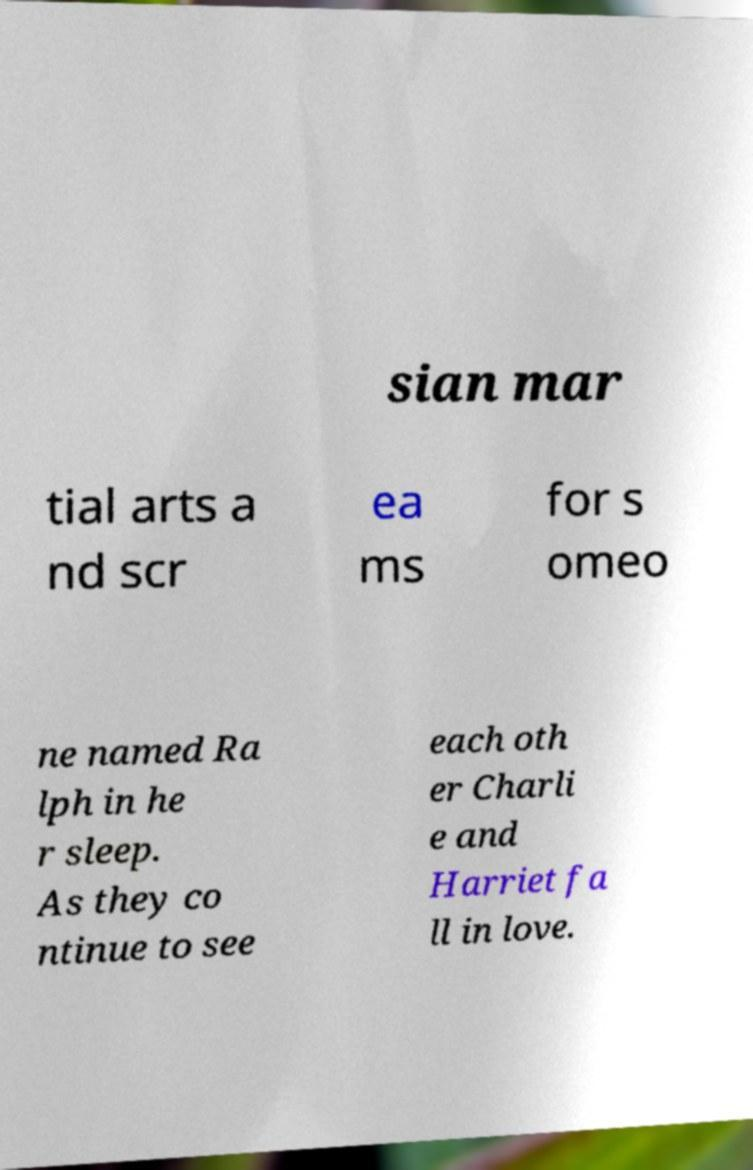For documentation purposes, I need the text within this image transcribed. Could you provide that? sian mar tial arts a nd scr ea ms for s omeo ne named Ra lph in he r sleep. As they co ntinue to see each oth er Charli e and Harriet fa ll in love. 